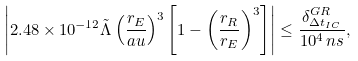Convert formula to latex. <formula><loc_0><loc_0><loc_500><loc_500>\left | 2 . 4 8 \times 1 0 ^ { - 1 2 } \tilde { \Lambda } \left ( \frac { r _ { E } } { a u } \right ) ^ { 3 } \left [ 1 - \left ( \frac { r _ { R } } { r _ { E } } \right ) ^ { 3 } \right ] \right | \leq \frac { \delta ^ { G R } _ { \Delta t _ { I C } } } { 1 0 ^ { 4 } \, n s } ,</formula> 